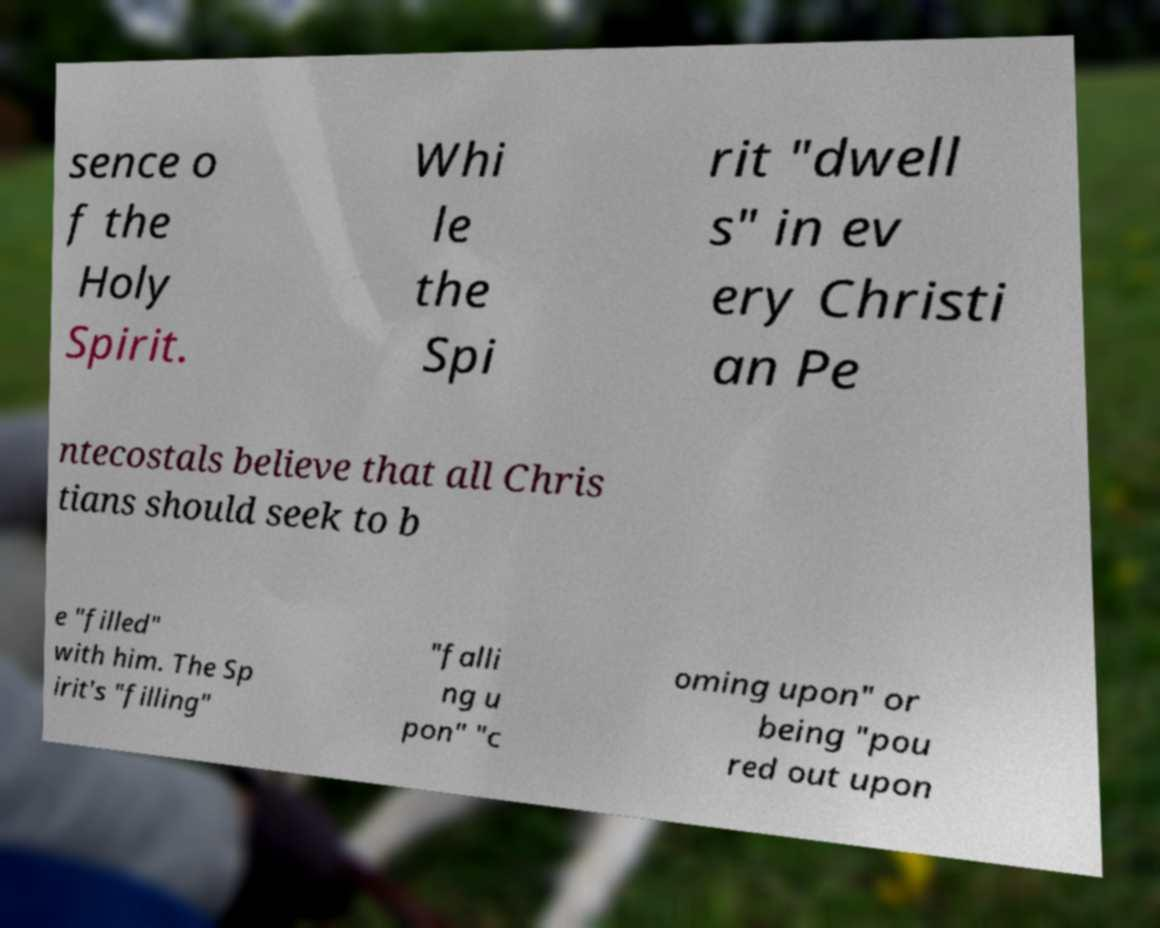For documentation purposes, I need the text within this image transcribed. Could you provide that? sence o f the Holy Spirit. Whi le the Spi rit "dwell s" in ev ery Christi an Pe ntecostals believe that all Chris tians should seek to b e "filled" with him. The Sp irit's "filling" "falli ng u pon" "c oming upon" or being "pou red out upon 